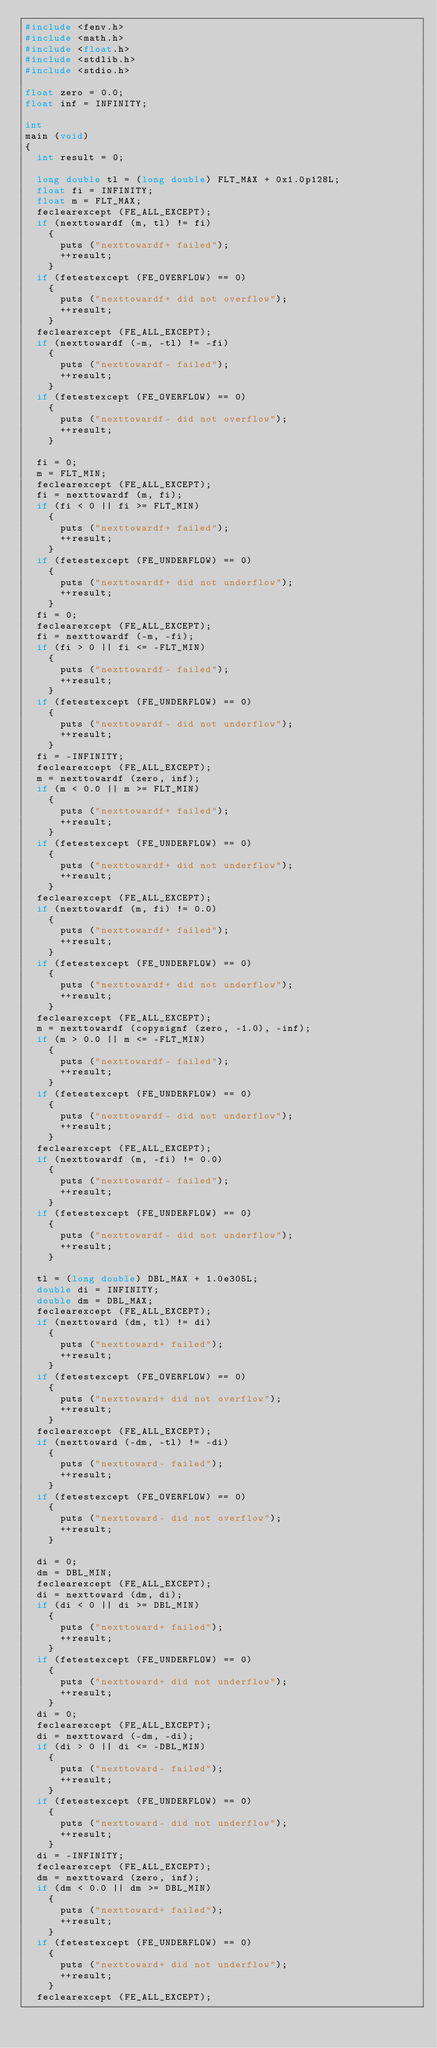<code> <loc_0><loc_0><loc_500><loc_500><_C_>#include <fenv.h>
#include <math.h>
#include <float.h>
#include <stdlib.h>
#include <stdio.h>

float zero = 0.0;
float inf = INFINITY;

int
main (void)
{
  int result = 0;

  long double tl = (long double) FLT_MAX + 0x1.0p128L;
  float fi = INFINITY;
  float m = FLT_MAX;
  feclearexcept (FE_ALL_EXCEPT);
  if (nexttowardf (m, tl) != fi)
    {
      puts ("nexttowardf+ failed");
      ++result;
    }
  if (fetestexcept (FE_OVERFLOW) == 0)
    {
      puts ("nexttowardf+ did not overflow");
      ++result;
    }
  feclearexcept (FE_ALL_EXCEPT);
  if (nexttowardf (-m, -tl) != -fi)
    {
      puts ("nexttowardf- failed");
      ++result;
    }
  if (fetestexcept (FE_OVERFLOW) == 0)
    {
      puts ("nexttowardf- did not overflow");
      ++result;
    }

  fi = 0;
  m = FLT_MIN;
  feclearexcept (FE_ALL_EXCEPT);
  fi = nexttowardf (m, fi);
  if (fi < 0 || fi >= FLT_MIN)
    {
      puts ("nexttowardf+ failed");
      ++result;
    }
  if (fetestexcept (FE_UNDERFLOW) == 0)
    {
      puts ("nexttowardf+ did not underflow");
      ++result;
    }
  fi = 0;
  feclearexcept (FE_ALL_EXCEPT);
  fi = nexttowardf (-m, -fi);
  if (fi > 0 || fi <= -FLT_MIN)
    {
      puts ("nexttowardf- failed");
      ++result;
    }
  if (fetestexcept (FE_UNDERFLOW) == 0)
    {
      puts ("nexttowardf- did not underflow");
      ++result;
    }
  fi = -INFINITY;
  feclearexcept (FE_ALL_EXCEPT);
  m = nexttowardf (zero, inf);
  if (m < 0.0 || m >= FLT_MIN)
    {
      puts ("nexttowardf+ failed");
      ++result;
    }
  if (fetestexcept (FE_UNDERFLOW) == 0)
    {
      puts ("nexttowardf+ did not underflow");
      ++result;
    }
  feclearexcept (FE_ALL_EXCEPT);
  if (nexttowardf (m, fi) != 0.0)
    {
      puts ("nexttowardf+ failed");
      ++result;
    }
  if (fetestexcept (FE_UNDERFLOW) == 0)
    {
      puts ("nexttowardf+ did not underflow");
      ++result;
    }
  feclearexcept (FE_ALL_EXCEPT);
  m = nexttowardf (copysignf (zero, -1.0), -inf);
  if (m > 0.0 || m <= -FLT_MIN)
    {
      puts ("nexttowardf- failed");
      ++result;
    }
  if (fetestexcept (FE_UNDERFLOW) == 0)
    {
      puts ("nexttowardf- did not underflow");
      ++result;
    }
  feclearexcept (FE_ALL_EXCEPT);
  if (nexttowardf (m, -fi) != 0.0)
    {
      puts ("nexttowardf- failed");
      ++result;
    }
  if (fetestexcept (FE_UNDERFLOW) == 0)
    {
      puts ("nexttowardf- did not underflow");
      ++result;
    }

  tl = (long double) DBL_MAX + 1.0e305L;
  double di = INFINITY;
  double dm = DBL_MAX;
  feclearexcept (FE_ALL_EXCEPT);
  if (nexttoward (dm, tl) != di)
    {
      puts ("nexttoward+ failed");
      ++result;
    }
  if (fetestexcept (FE_OVERFLOW) == 0)
    {
      puts ("nexttoward+ did not overflow");
      ++result;
    }
  feclearexcept (FE_ALL_EXCEPT);
  if (nexttoward (-dm, -tl) != -di)
    {
      puts ("nexttoward- failed");
      ++result;
    }
  if (fetestexcept (FE_OVERFLOW) == 0)
    {
      puts ("nexttoward- did not overflow");
      ++result;
    }

  di = 0;
  dm = DBL_MIN;
  feclearexcept (FE_ALL_EXCEPT);
  di = nexttoward (dm, di);
  if (di < 0 || di >= DBL_MIN)
    {
      puts ("nexttoward+ failed");
      ++result;
    }
  if (fetestexcept (FE_UNDERFLOW) == 0)
    {
      puts ("nexttoward+ did not underflow");
      ++result;
    }
  di = 0;
  feclearexcept (FE_ALL_EXCEPT);
  di = nexttoward (-dm, -di);
  if (di > 0 || di <= -DBL_MIN)
    {
      puts ("nexttoward- failed");
      ++result;
    }
  if (fetestexcept (FE_UNDERFLOW) == 0)
    {
      puts ("nexttoward- did not underflow");
      ++result;
    }
  di = -INFINITY;
  feclearexcept (FE_ALL_EXCEPT);
  dm = nexttoward (zero, inf);
  if (dm < 0.0 || dm >= DBL_MIN)
    {
      puts ("nexttoward+ failed");
      ++result;
    }
  if (fetestexcept (FE_UNDERFLOW) == 0)
    {
      puts ("nexttoward+ did not underflow");
      ++result;
    }
  feclearexcept (FE_ALL_EXCEPT);</code> 